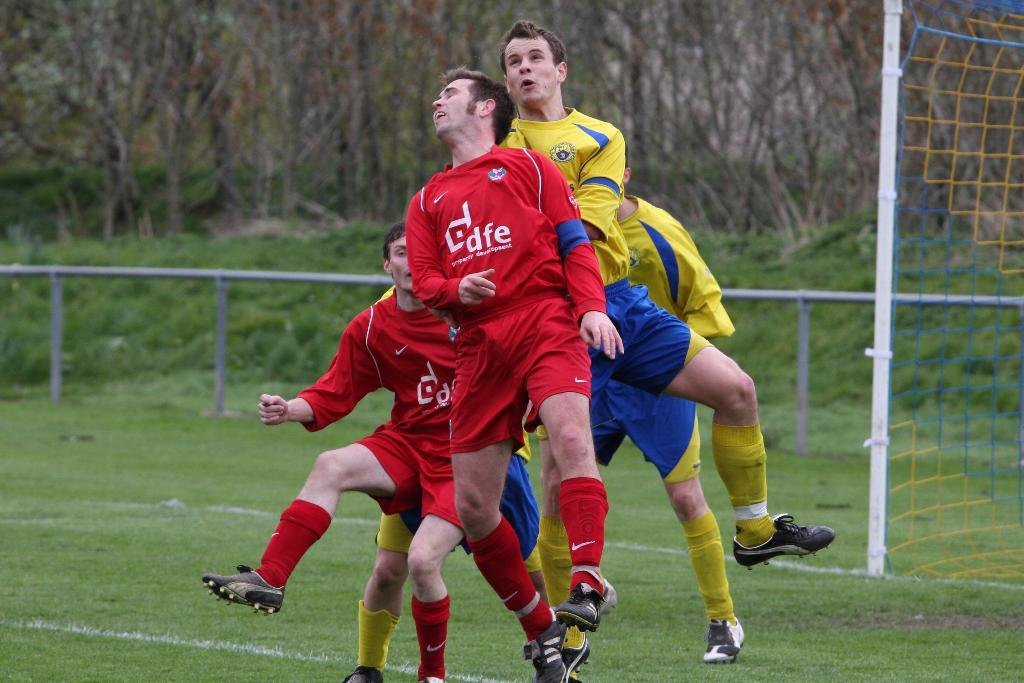<image>
Offer a succinct explanation of the picture presented. DFE soccer players blocking a goal at the end field 